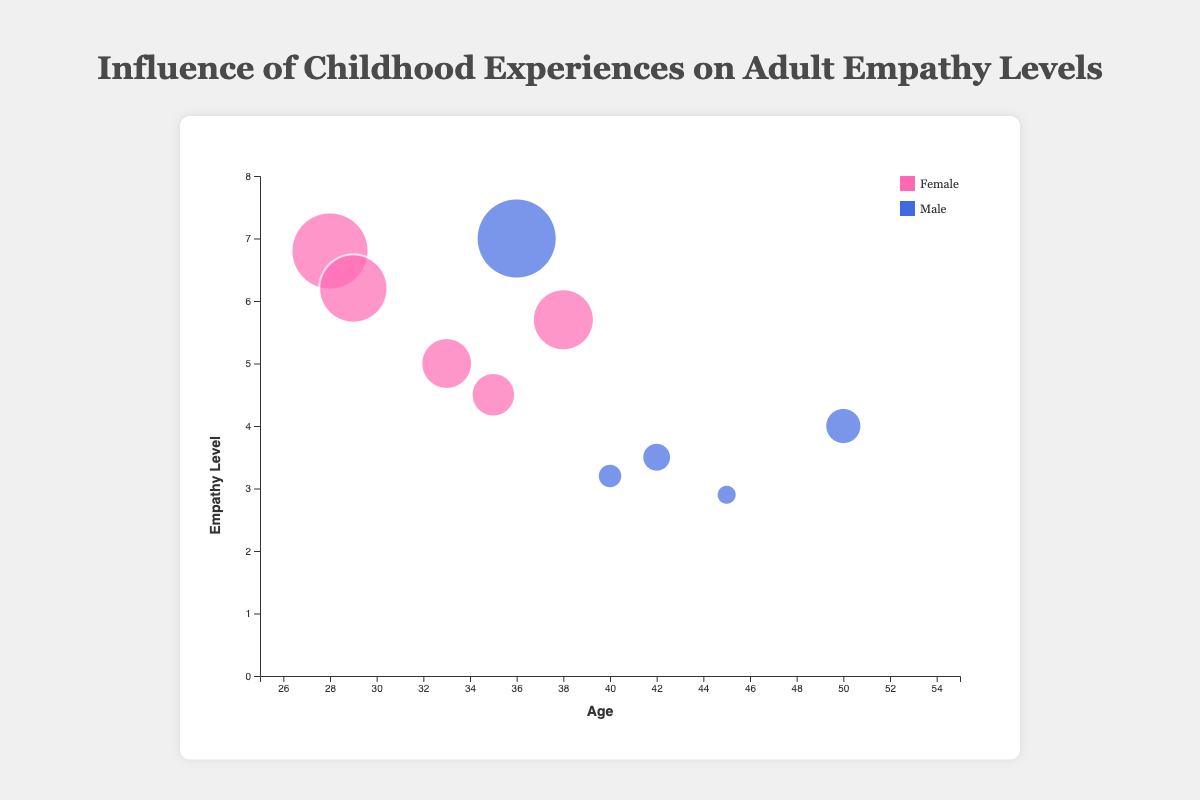How many different types of childhood experiences are presented in the chart? Count the unique childhood experiences listed in the data. There are 10 distinct experiences.
Answer: 10 Which childhood experience is associated with the lowest empathy level? Look at the y-axis (Empathy Level) and identify which bubble has the lowest position. It corresponds to "Physical Abuse" with an empathy level of 2.9.
Answer: Physical Abuse What is the empathy level for males who experienced early loss of a parent? Find the bubble that represents "Early Loss of Parent" and is colored for males (blue). The empathy level is 4.0.
Answer: 4.0 How many females are represented in the chart? Count all the bubbles that are colored differently (presumed pink for females). There are 5 such bubbles.
Answer: 5 Which childhood experience has the highest empathy level and what age group does it belong to? Identify the bubble with the highest position on the y-axis. Check the corresponding childhood experience and age. "Parental Encouragement" at the empathy level of 7.0 corresponds to the age of 36.
Answer: Parental Encouragement, 36 Which gender shows more variability in empathy levels based on the chart? Vanishing between different empathy levels and gender colors; males have empathy levels ranging from 2.9 to 7.0, while females range from 4.5 to 6.8. Males have a broader range.
Answer: Males What is the average empathy level for individuals aged 35 and over? Identify the bubbles for ages 35, 40, 45, 50, and 42. Sum their empathy levels (4.5 + 3.2 + 2.9 + 4.0 + 3.5 = 18.1) and divide by the number of individuals (5). The average empathy level is 18.1 / 5 = 3.62.
Answer: 3.62 How does parental support compare to parental encouragement in terms of empathy levels? Identify the bubbles for "Parental Support" (6.8) and "Parental Encouragement" (7.0) and compare their positions on the y-axis. "Parental Encouragement" is slightly higher.
Answer: Parental Encouragement is higher What type of childhood experience shows the largest bubble, and what does it represent? The largest bubble size should correspond to the highest empathy level on the y-axis. It represents "Parental Encouragement" at 7.0.
Answer: Parental Encouragement What character trait is associated with experiencing chronic illness in the family, and what gender shows this experience? Identify the bubble for "Chronic Illness in Family" and check the tooltip details. It shows "Compassionate" character and is colored for females.
Answer: Compassionate, Female 